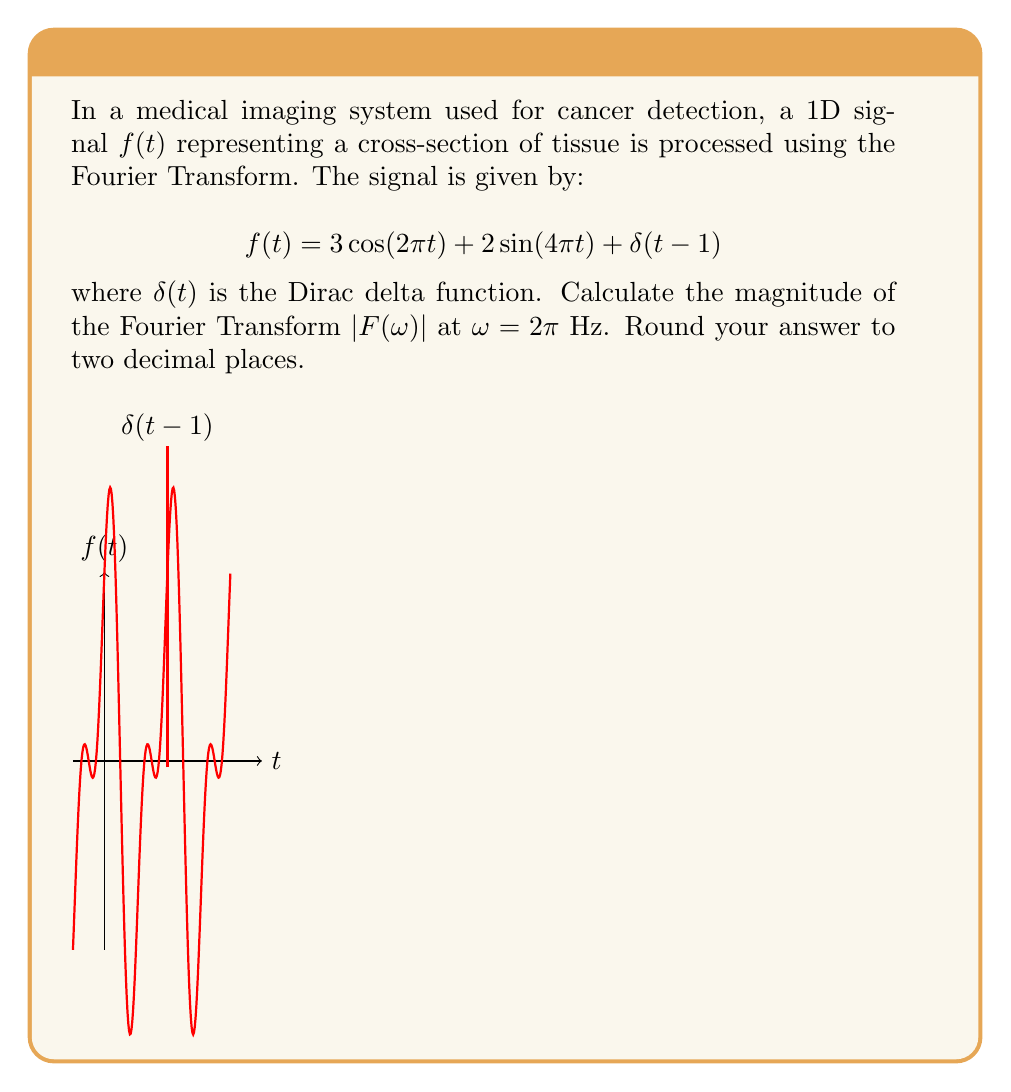Help me with this question. Let's approach this step-by-step:

1) The Fourier Transform of $f(t)$ is given by:
   $$F(\omega) = \int_{-\infty}^{\infty} f(t) e^{-i\omega t} dt$$

2) We need to calculate $F(\omega)$ for each term in $f(t)$ separately:

   a) For $3\cos(2\pi t)$:
      $$F_1(\omega) = \frac{3}{2}[\delta(\omega-2\pi) + \delta(\omega+2\pi)]$$

   b) For $2\sin(4\pi t)$:
      $$F_2(\omega) = i[\delta(\omega-4\pi) - \delta(\omega+4\pi)]$$

   c) For $\delta(t-1)$:
      $$F_3(\omega) = e^{-i\omega}$$

3) The total Fourier Transform is the sum of these components:
   $$F(\omega) = F_1(\omega) + F_2(\omega) + F_3(\omega)$$

4) At $\omega = 2\pi$, only $F_1$ and $F_3$ contribute:
   $$F(2\pi) = \frac{3}{2} + e^{-i2\pi} = \frac{3}{2} + 1 = \frac{5}{2}$$

5) The magnitude is:
   $$|F(2\pi)| = |\frac{5}{2}| = 2.5$$

6) Rounding to two decimal places: 2.50

This enhancement in the frequency domain can help isolate specific tissue characteristics, potentially improving cancer detection accuracy.
Answer: 2.50 